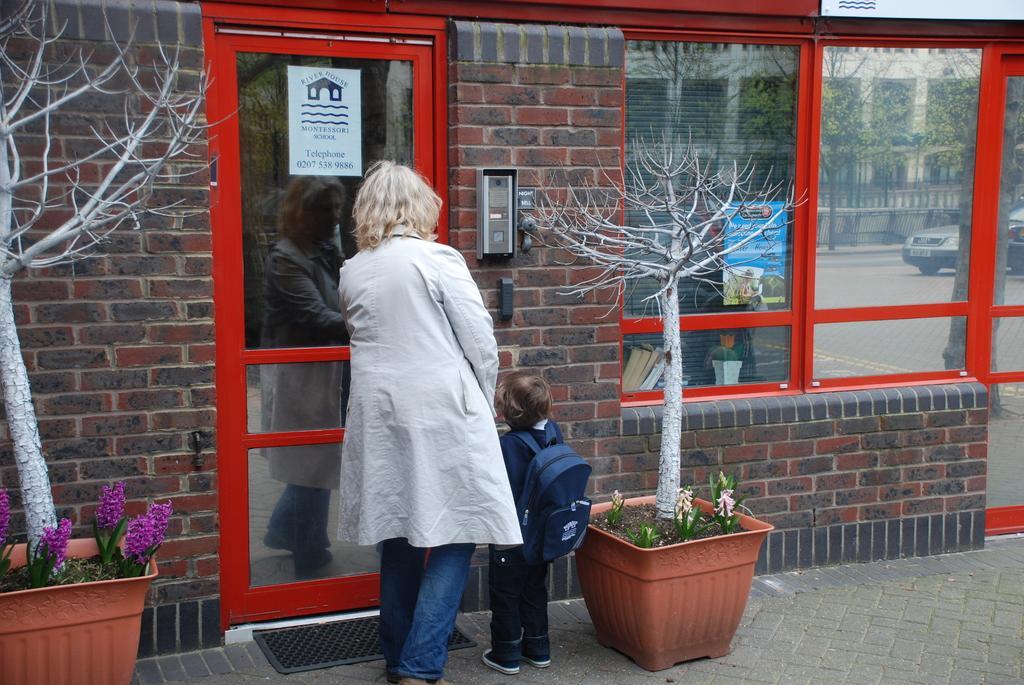In one or two sentences, can you explain what this image depicts? In this picture we can see astore with bricks and this is a door. These are the bare trees. These are the pots and there are few plants in it. We can see a woman and a baby trying to enter into the store. This is the road. 